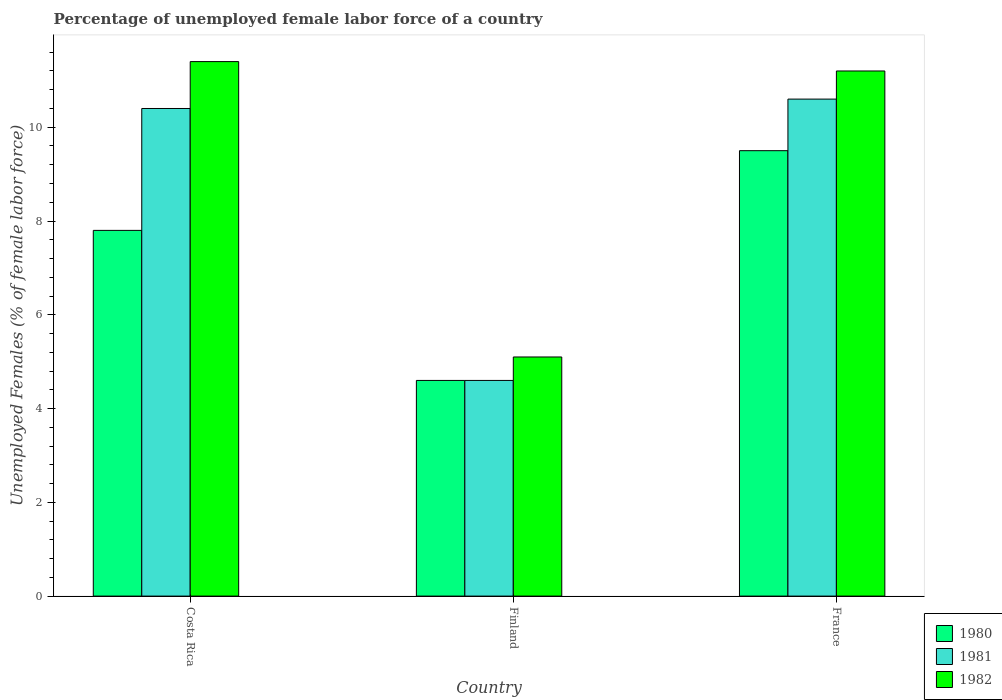Are the number of bars per tick equal to the number of legend labels?
Provide a succinct answer. Yes. Are the number of bars on each tick of the X-axis equal?
Make the answer very short. Yes. What is the percentage of unemployed female labor force in 1981 in Finland?
Provide a succinct answer. 4.6. Across all countries, what is the maximum percentage of unemployed female labor force in 1981?
Make the answer very short. 10.6. Across all countries, what is the minimum percentage of unemployed female labor force in 1981?
Offer a terse response. 4.6. In which country was the percentage of unemployed female labor force in 1982 maximum?
Provide a succinct answer. Costa Rica. In which country was the percentage of unemployed female labor force in 1982 minimum?
Keep it short and to the point. Finland. What is the total percentage of unemployed female labor force in 1981 in the graph?
Provide a succinct answer. 25.6. What is the difference between the percentage of unemployed female labor force in 1981 in Costa Rica and that in France?
Your response must be concise. -0.2. What is the difference between the percentage of unemployed female labor force in 1981 in France and the percentage of unemployed female labor force in 1980 in Costa Rica?
Your response must be concise. 2.8. What is the average percentage of unemployed female labor force in 1980 per country?
Ensure brevity in your answer.  7.3. What is the difference between the percentage of unemployed female labor force of/in 1981 and percentage of unemployed female labor force of/in 1980 in Costa Rica?
Your response must be concise. 2.6. In how many countries, is the percentage of unemployed female labor force in 1980 greater than 2.4 %?
Offer a very short reply. 3. What is the ratio of the percentage of unemployed female labor force in 1980 in Costa Rica to that in France?
Ensure brevity in your answer.  0.82. Is the percentage of unemployed female labor force in 1982 in Costa Rica less than that in Finland?
Keep it short and to the point. No. Is the difference between the percentage of unemployed female labor force in 1981 in Finland and France greater than the difference between the percentage of unemployed female labor force in 1980 in Finland and France?
Provide a short and direct response. No. What is the difference between the highest and the second highest percentage of unemployed female labor force in 1980?
Offer a terse response. 4.9. What is the difference between the highest and the lowest percentage of unemployed female labor force in 1982?
Offer a terse response. 6.3. In how many countries, is the percentage of unemployed female labor force in 1981 greater than the average percentage of unemployed female labor force in 1981 taken over all countries?
Your answer should be compact. 2. What does the 3rd bar from the left in Costa Rica represents?
Your response must be concise. 1982. What does the 1st bar from the right in Finland represents?
Offer a terse response. 1982. Is it the case that in every country, the sum of the percentage of unemployed female labor force in 1982 and percentage of unemployed female labor force in 1981 is greater than the percentage of unemployed female labor force in 1980?
Ensure brevity in your answer.  Yes. How many bars are there?
Provide a short and direct response. 9. Are all the bars in the graph horizontal?
Offer a very short reply. No. What is the difference between two consecutive major ticks on the Y-axis?
Your answer should be compact. 2. Are the values on the major ticks of Y-axis written in scientific E-notation?
Keep it short and to the point. No. Does the graph contain any zero values?
Provide a succinct answer. No. Does the graph contain grids?
Give a very brief answer. No. Where does the legend appear in the graph?
Ensure brevity in your answer.  Bottom right. What is the title of the graph?
Your answer should be very brief. Percentage of unemployed female labor force of a country. Does "1976" appear as one of the legend labels in the graph?
Your answer should be very brief. No. What is the label or title of the Y-axis?
Provide a short and direct response. Unemployed Females (% of female labor force). What is the Unemployed Females (% of female labor force) in 1980 in Costa Rica?
Make the answer very short. 7.8. What is the Unemployed Females (% of female labor force) in 1981 in Costa Rica?
Your answer should be very brief. 10.4. What is the Unemployed Females (% of female labor force) of 1982 in Costa Rica?
Offer a very short reply. 11.4. What is the Unemployed Females (% of female labor force) of 1980 in Finland?
Offer a terse response. 4.6. What is the Unemployed Females (% of female labor force) in 1981 in Finland?
Keep it short and to the point. 4.6. What is the Unemployed Females (% of female labor force) of 1982 in Finland?
Your answer should be compact. 5.1. What is the Unemployed Females (% of female labor force) of 1981 in France?
Make the answer very short. 10.6. What is the Unemployed Females (% of female labor force) of 1982 in France?
Give a very brief answer. 11.2. Across all countries, what is the maximum Unemployed Females (% of female labor force) in 1980?
Offer a very short reply. 9.5. Across all countries, what is the maximum Unemployed Females (% of female labor force) of 1981?
Keep it short and to the point. 10.6. Across all countries, what is the maximum Unemployed Females (% of female labor force) in 1982?
Offer a terse response. 11.4. Across all countries, what is the minimum Unemployed Females (% of female labor force) of 1980?
Keep it short and to the point. 4.6. Across all countries, what is the minimum Unemployed Females (% of female labor force) in 1981?
Your answer should be very brief. 4.6. Across all countries, what is the minimum Unemployed Females (% of female labor force) of 1982?
Make the answer very short. 5.1. What is the total Unemployed Females (% of female labor force) of 1980 in the graph?
Offer a terse response. 21.9. What is the total Unemployed Females (% of female labor force) in 1981 in the graph?
Provide a succinct answer. 25.6. What is the total Unemployed Females (% of female labor force) of 1982 in the graph?
Your answer should be very brief. 27.7. What is the difference between the Unemployed Females (% of female labor force) in 1980 in Costa Rica and that in Finland?
Offer a very short reply. 3.2. What is the difference between the Unemployed Females (% of female labor force) in 1981 in Costa Rica and that in France?
Make the answer very short. -0.2. What is the difference between the Unemployed Females (% of female labor force) in 1982 in Costa Rica and that in France?
Keep it short and to the point. 0.2. What is the difference between the Unemployed Females (% of female labor force) of 1981 in Finland and that in France?
Give a very brief answer. -6. What is the difference between the Unemployed Females (% of female labor force) of 1982 in Finland and that in France?
Your answer should be very brief. -6.1. What is the difference between the Unemployed Females (% of female labor force) in 1980 in Costa Rica and the Unemployed Females (% of female labor force) in 1982 in France?
Keep it short and to the point. -3.4. What is the difference between the Unemployed Females (% of female labor force) in 1980 in Finland and the Unemployed Females (% of female labor force) in 1982 in France?
Offer a very short reply. -6.6. What is the difference between the Unemployed Females (% of female labor force) in 1981 in Finland and the Unemployed Females (% of female labor force) in 1982 in France?
Provide a short and direct response. -6.6. What is the average Unemployed Females (% of female labor force) in 1980 per country?
Offer a terse response. 7.3. What is the average Unemployed Females (% of female labor force) of 1981 per country?
Provide a succinct answer. 8.53. What is the average Unemployed Females (% of female labor force) of 1982 per country?
Your answer should be compact. 9.23. What is the difference between the Unemployed Females (% of female labor force) of 1980 and Unemployed Females (% of female labor force) of 1981 in Costa Rica?
Make the answer very short. -2.6. What is the difference between the Unemployed Females (% of female labor force) in 1981 and Unemployed Females (% of female labor force) in 1982 in France?
Offer a very short reply. -0.6. What is the ratio of the Unemployed Females (% of female labor force) in 1980 in Costa Rica to that in Finland?
Your answer should be very brief. 1.7. What is the ratio of the Unemployed Females (% of female labor force) in 1981 in Costa Rica to that in Finland?
Give a very brief answer. 2.26. What is the ratio of the Unemployed Females (% of female labor force) in 1982 in Costa Rica to that in Finland?
Provide a succinct answer. 2.24. What is the ratio of the Unemployed Females (% of female labor force) in 1980 in Costa Rica to that in France?
Your response must be concise. 0.82. What is the ratio of the Unemployed Females (% of female labor force) of 1981 in Costa Rica to that in France?
Offer a terse response. 0.98. What is the ratio of the Unemployed Females (% of female labor force) in 1982 in Costa Rica to that in France?
Keep it short and to the point. 1.02. What is the ratio of the Unemployed Females (% of female labor force) in 1980 in Finland to that in France?
Give a very brief answer. 0.48. What is the ratio of the Unemployed Females (% of female labor force) of 1981 in Finland to that in France?
Make the answer very short. 0.43. What is the ratio of the Unemployed Females (% of female labor force) in 1982 in Finland to that in France?
Offer a very short reply. 0.46. What is the difference between the highest and the second highest Unemployed Females (% of female labor force) of 1980?
Your response must be concise. 1.7. What is the difference between the highest and the second highest Unemployed Females (% of female labor force) of 1982?
Give a very brief answer. 0.2. What is the difference between the highest and the lowest Unemployed Females (% of female labor force) of 1981?
Provide a short and direct response. 6. What is the difference between the highest and the lowest Unemployed Females (% of female labor force) in 1982?
Keep it short and to the point. 6.3. 